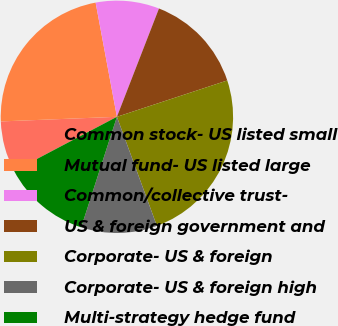<chart> <loc_0><loc_0><loc_500><loc_500><pie_chart><fcel>Common stock- US listed small<fcel>Mutual fund- US listed large<fcel>Common/collective trust-<fcel>US & foreign government and<fcel>Corporate- US & foreign<fcel>Corporate- US & foreign high<fcel>Multi-strategy hedge fund<nl><fcel>7.09%<fcel>22.7%<fcel>8.83%<fcel>14.04%<fcel>24.47%<fcel>10.57%<fcel>12.3%<nl></chart> 